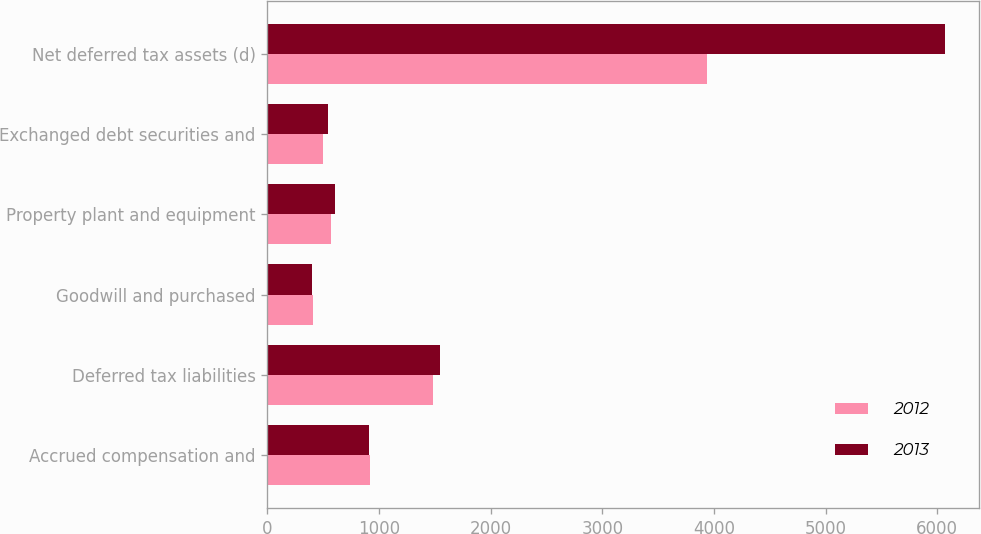Convert chart to OTSL. <chart><loc_0><loc_0><loc_500><loc_500><stacked_bar_chart><ecel><fcel>Accrued compensation and<fcel>Deferred tax liabilities<fcel>Goodwill and purchased<fcel>Property plant and equipment<fcel>Exchanged debt securities and<fcel>Net deferred tax assets (d)<nl><fcel>2012<fcel>918<fcel>1487<fcel>410<fcel>575<fcel>502<fcel>3933<nl><fcel>2013<fcel>909<fcel>1550<fcel>402<fcel>604<fcel>544<fcel>6072<nl></chart> 